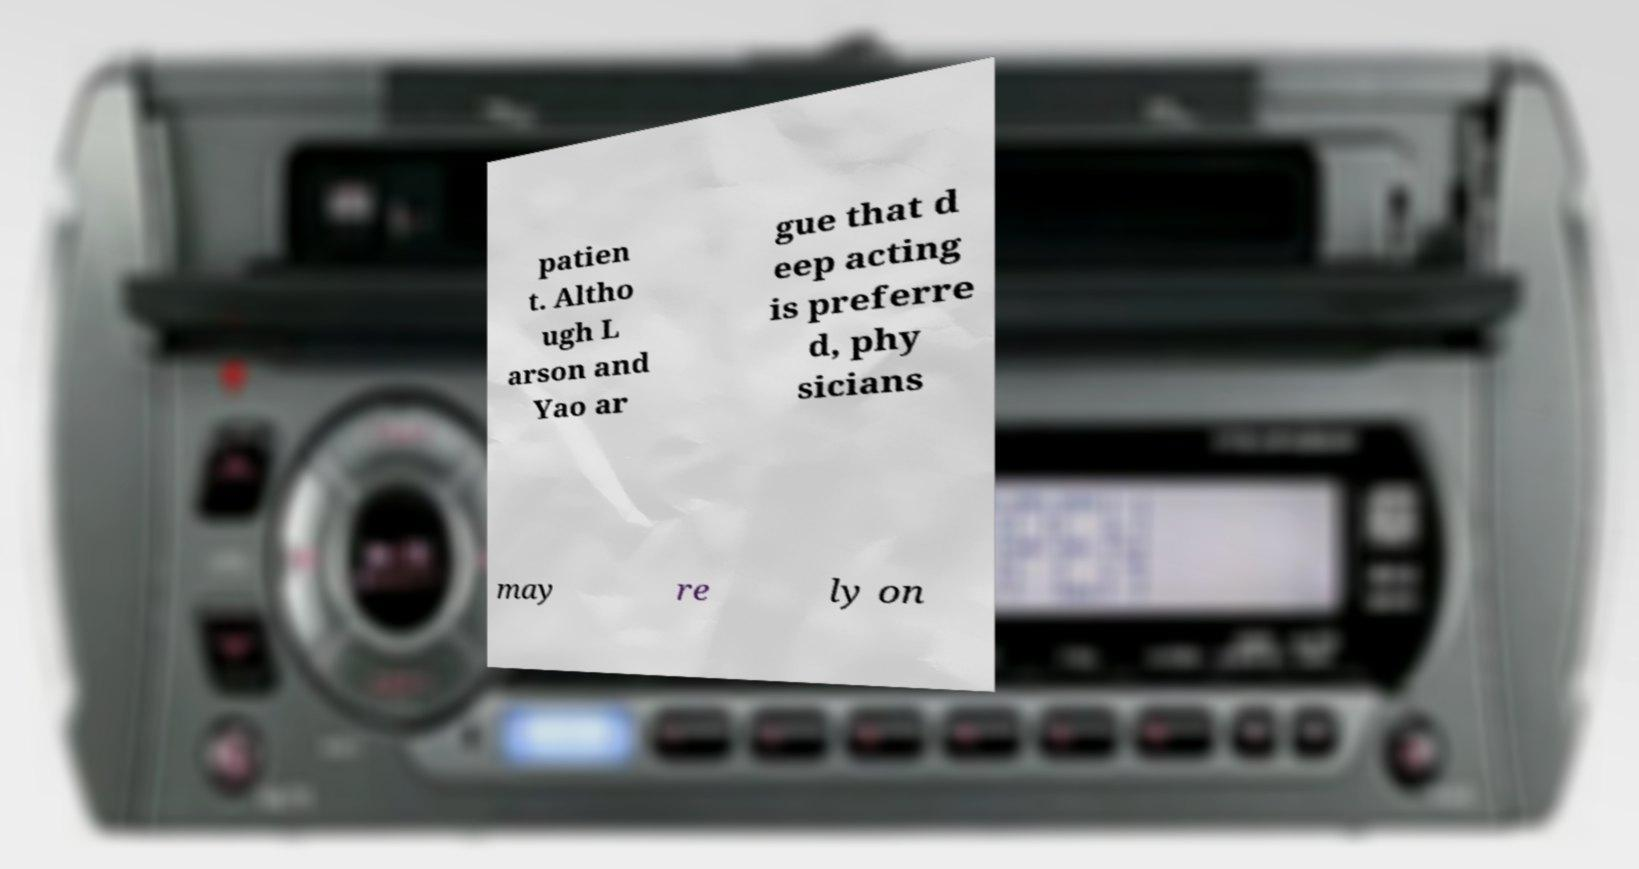I need the written content from this picture converted into text. Can you do that? patien t. Altho ugh L arson and Yao ar gue that d eep acting is preferre d, phy sicians may re ly on 